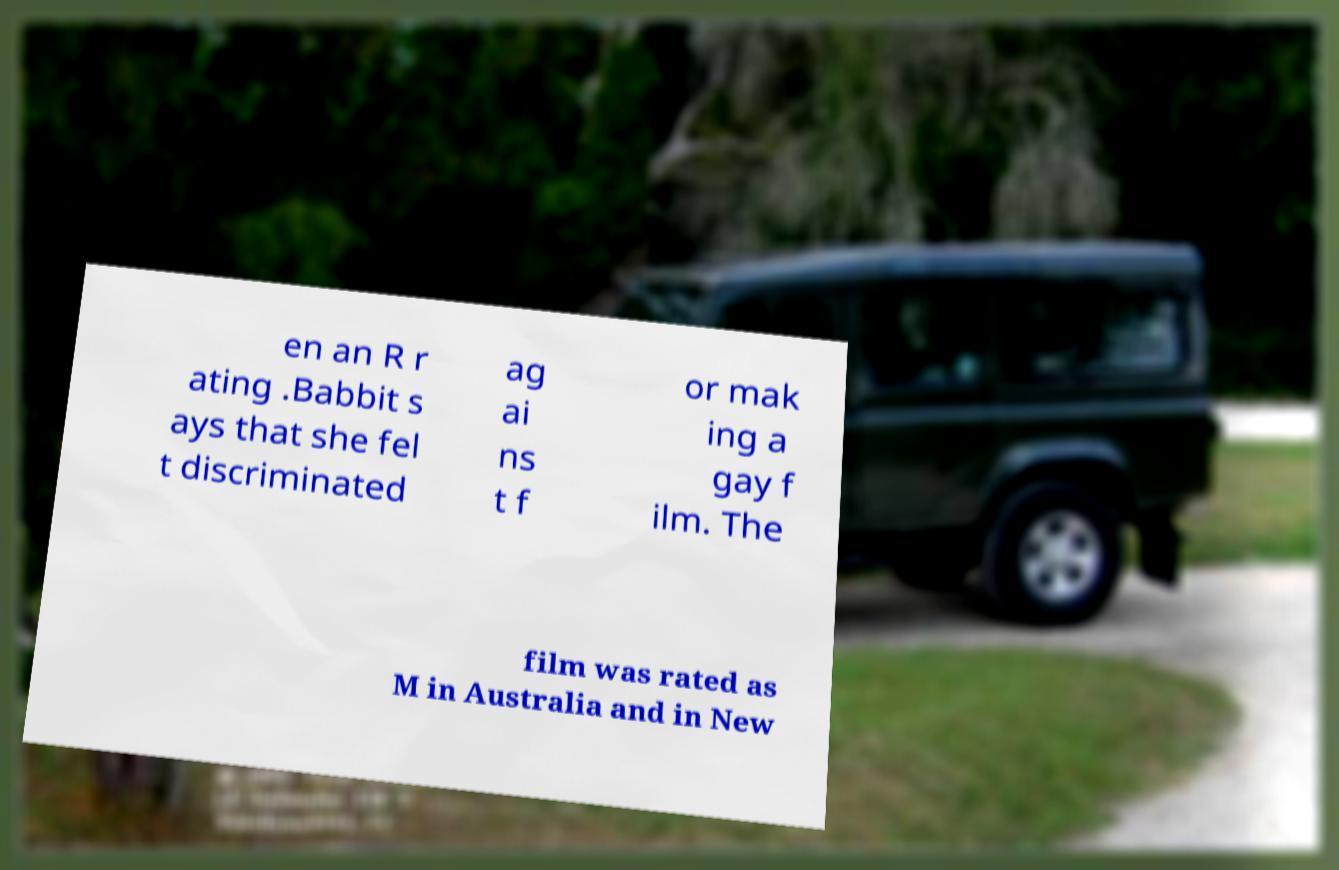Can you accurately transcribe the text from the provided image for me? en an R r ating .Babbit s ays that she fel t discriminated ag ai ns t f or mak ing a gay f ilm. The film was rated as M in Australia and in New 